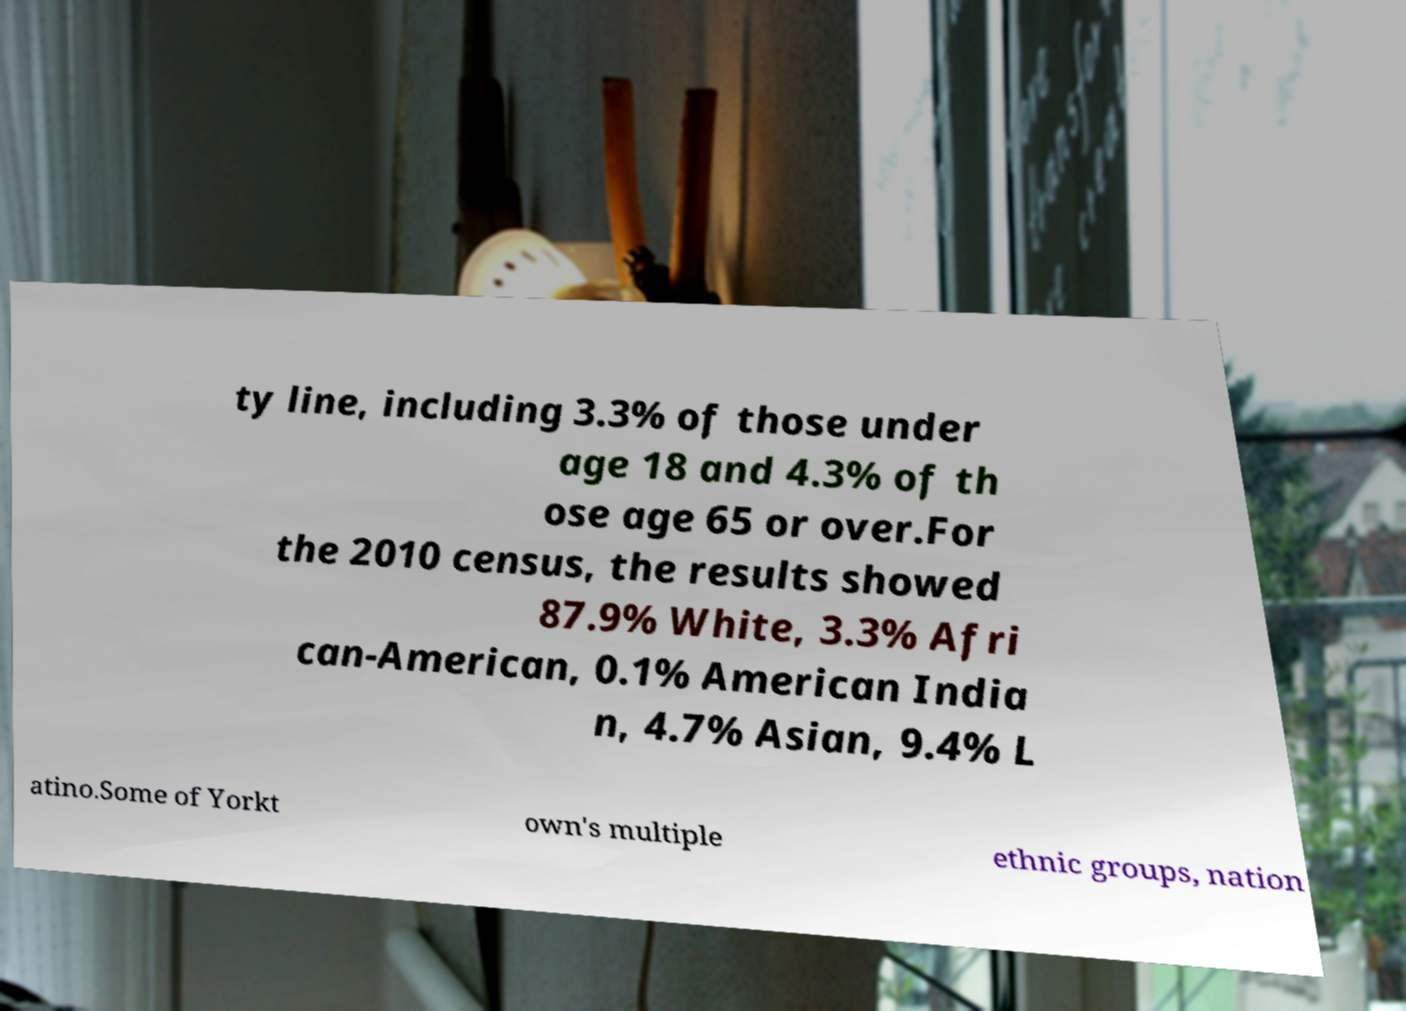Can you read and provide the text displayed in the image?This photo seems to have some interesting text. Can you extract and type it out for me? ty line, including 3.3% of those under age 18 and 4.3% of th ose age 65 or over.For the 2010 census, the results showed 87.9% White, 3.3% Afri can-American, 0.1% American India n, 4.7% Asian, 9.4% L atino.Some of Yorkt own's multiple ethnic groups, nation 